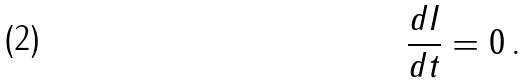Convert formula to latex. <formula><loc_0><loc_0><loc_500><loc_500>\frac { d I } { d t } = 0 \, .</formula> 